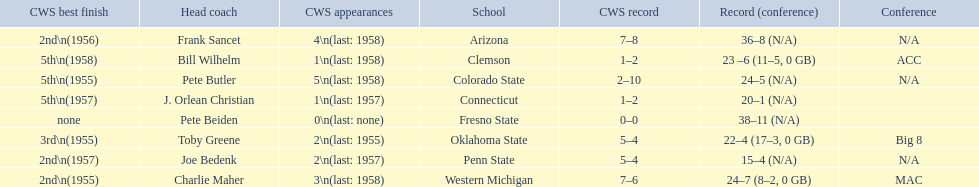Which teams played in the 1959 ncaa university division baseball tournament? Arizona, Clemson, Colorado State, Connecticut, Fresno State, Oklahoma State, Penn State, Western Michigan. Which was the only one to win less than 20 games? Penn State. 